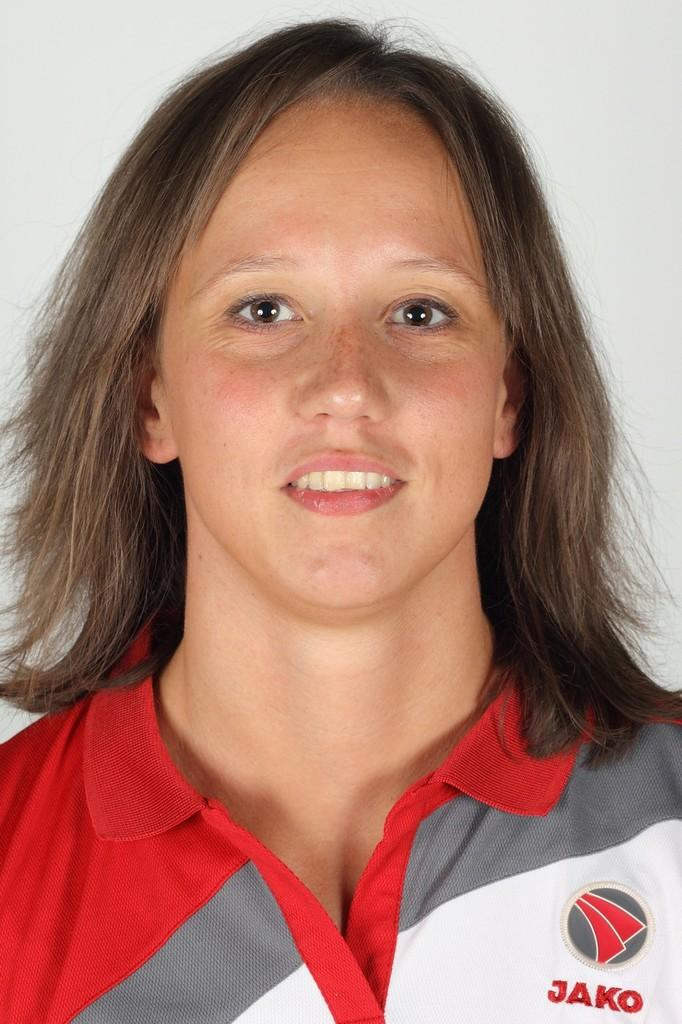<image>
Create a compact narrative representing the image presented. A red, gray and white shirt with the logo for Jako is being worn by a woman. 